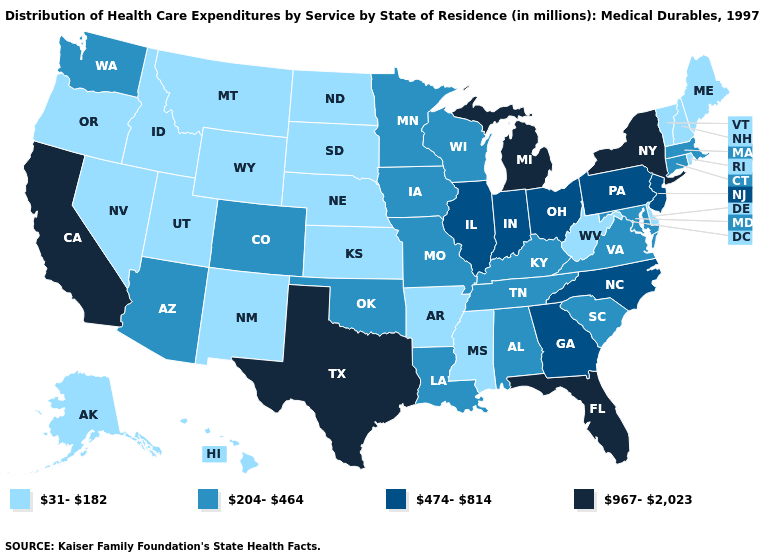Name the states that have a value in the range 31-182?
Answer briefly. Alaska, Arkansas, Delaware, Hawaii, Idaho, Kansas, Maine, Mississippi, Montana, Nebraska, Nevada, New Hampshire, New Mexico, North Dakota, Oregon, Rhode Island, South Dakota, Utah, Vermont, West Virginia, Wyoming. Among the states that border Kentucky , which have the lowest value?
Keep it brief. West Virginia. Name the states that have a value in the range 204-464?
Give a very brief answer. Alabama, Arizona, Colorado, Connecticut, Iowa, Kentucky, Louisiana, Maryland, Massachusetts, Minnesota, Missouri, Oklahoma, South Carolina, Tennessee, Virginia, Washington, Wisconsin. What is the value of Colorado?
Be succinct. 204-464. Is the legend a continuous bar?
Short answer required. No. Name the states that have a value in the range 204-464?
Answer briefly. Alabama, Arizona, Colorado, Connecticut, Iowa, Kentucky, Louisiana, Maryland, Massachusetts, Minnesota, Missouri, Oklahoma, South Carolina, Tennessee, Virginia, Washington, Wisconsin. What is the value of North Dakota?
Give a very brief answer. 31-182. Among the states that border Wisconsin , which have the lowest value?
Concise answer only. Iowa, Minnesota. Among the states that border Minnesota , does South Dakota have the lowest value?
Be succinct. Yes. Name the states that have a value in the range 31-182?
Be succinct. Alaska, Arkansas, Delaware, Hawaii, Idaho, Kansas, Maine, Mississippi, Montana, Nebraska, Nevada, New Hampshire, New Mexico, North Dakota, Oregon, Rhode Island, South Dakota, Utah, Vermont, West Virginia, Wyoming. What is the lowest value in the USA?
Quick response, please. 31-182. What is the value of Minnesota?
Short answer required. 204-464. How many symbols are there in the legend?
Keep it brief. 4. Which states have the highest value in the USA?
Answer briefly. California, Florida, Michigan, New York, Texas. What is the lowest value in the USA?
Concise answer only. 31-182. 